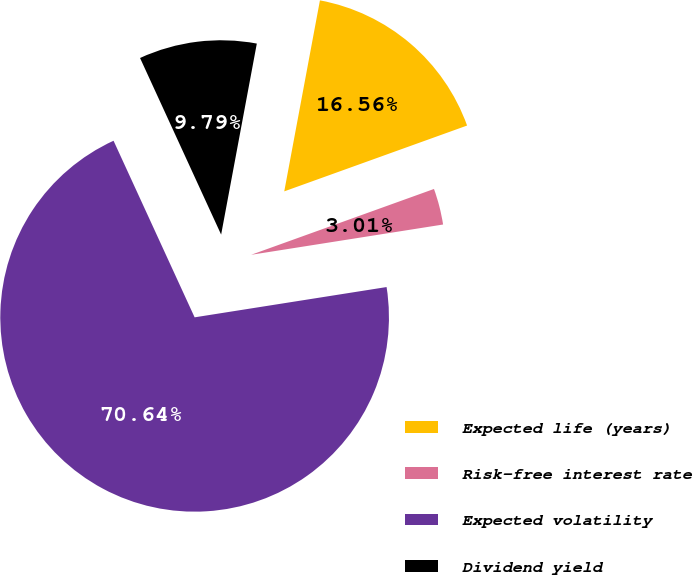Convert chart to OTSL. <chart><loc_0><loc_0><loc_500><loc_500><pie_chart><fcel>Expected life (years)<fcel>Risk-free interest rate<fcel>Expected volatility<fcel>Dividend yield<nl><fcel>16.56%<fcel>3.01%<fcel>70.64%<fcel>9.79%<nl></chart> 